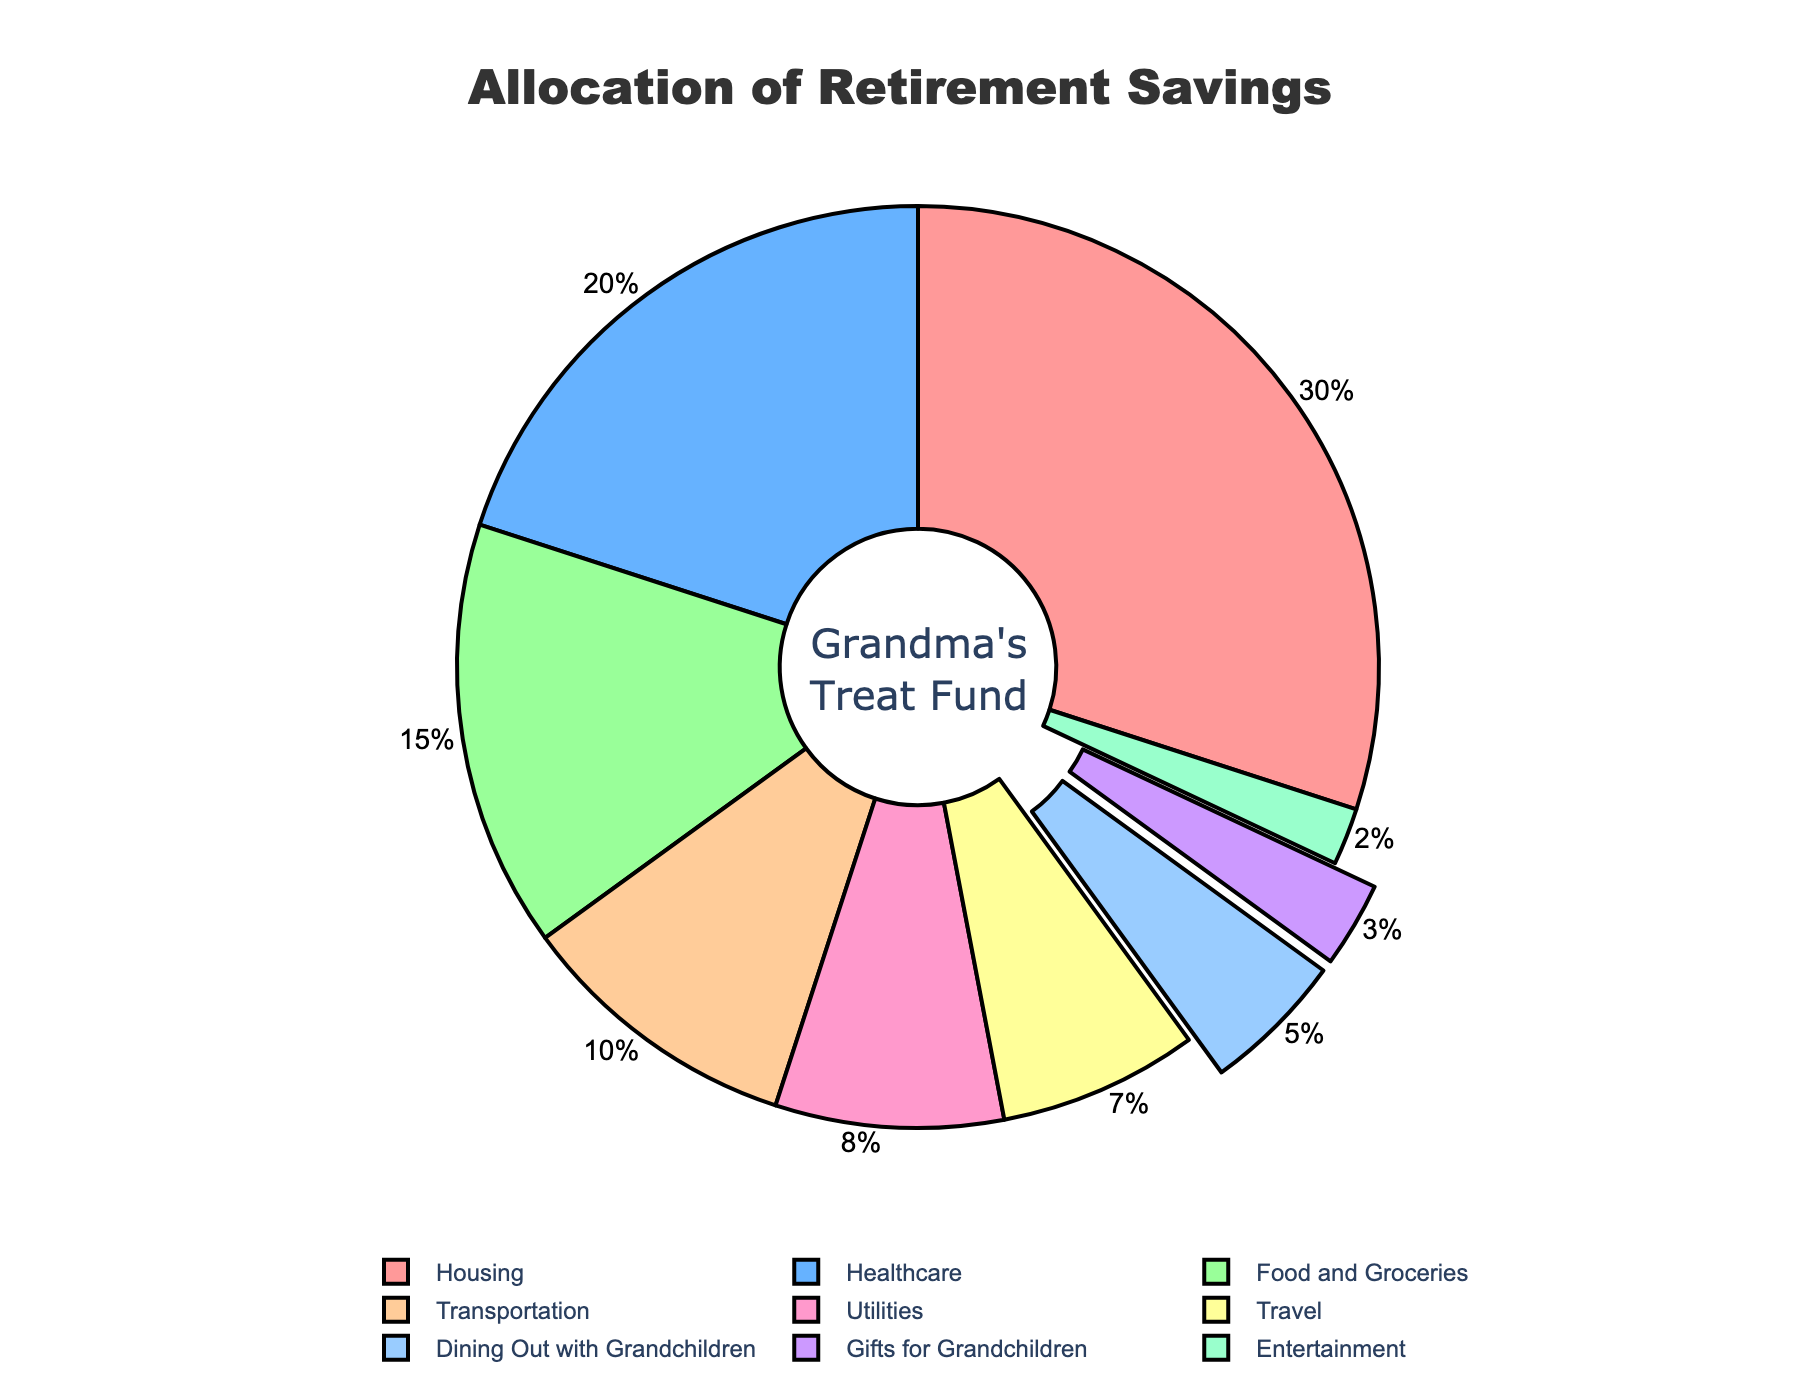What are the top three expense categories in terms of retirement savings allocation? Looking at the pie chart, the slices with the largest percentages are easily identifiable. They are Housing (30%), Healthcare (20%), and Food and Groceries (15%).
Answer: Housing, Healthcare, Food and Groceries What is the combined percentage of the savings allocated for Dining Out with Grandchildren and Gifts for Grandchildren? Add the percentages for Dining Out with Grandchildren (5%) and Gifts for Grandchildren (3%). The total is 5% + 3% = 8%.
Answer: 8% Which expense category has the smallest percentage allocation in retirement savings? By quickly scanning the slices of the pie chart, the smallest slice corresponds to Entertainment which has 2%.
Answer: Entertainment How does the allocation for Travel compare to the allocation for Transportation? The chart shows that Travel has a 7% allocation whereas Transportation has a 10% allocation. Since 10% is greater than 7%, Transportation has a higher allocation.
Answer: Transportation has a higher allocation What is the combined percentage allocation for Housing, Utilities, and Travel? Sum the percentages for Housing (30%), Utilities (8%), and Travel (7%). The total is 30% + 8% + 7% = 45%.
Answer: 45% If we wanted to equally reallocate the Dining Out with Grandchildren and Gifts for Grandchildren percentages to total 8%, what would each category receive? Since the combined total is already 8%, we divide by 2. So, each category would receive 8% / 2 = 4%.
Answer: 4% If the Healthcare allocation were increased by 10%, what would the new percentage be? The current Healthcare allocation is 20%. Increasing it by 10% would result in 20% + 10% = 30%.
Answer: 30% Which category has a higher allocation: Food and Groceries or Dining Out with Grandchildren and Gifts for Grandchildren combined? Food and Groceries has a 15% allocation. Dining Out with Grandchildren (5%) and Gifts for Grandchildren (3%) combined is 5% + 3% = 8%. 15% is greater than 8%.
Answer: Food and Groceries What is the difference in allocation between Housing and the total percentage allocated for grandchildren's treats? The allocation for Housing is 30%. The total allocation for grandchildren's treats (Dining Out and Gifts) is 5% + 3% = 8%. The difference is 30% - 8% = 22%.
Answer: 22% If the allocation for Entertainment were to double, what would its new percentage be? The current allocation for Entertainment is 2%. Doubling this amount would result in 2% * 2 = 4%.
Answer: 4% 